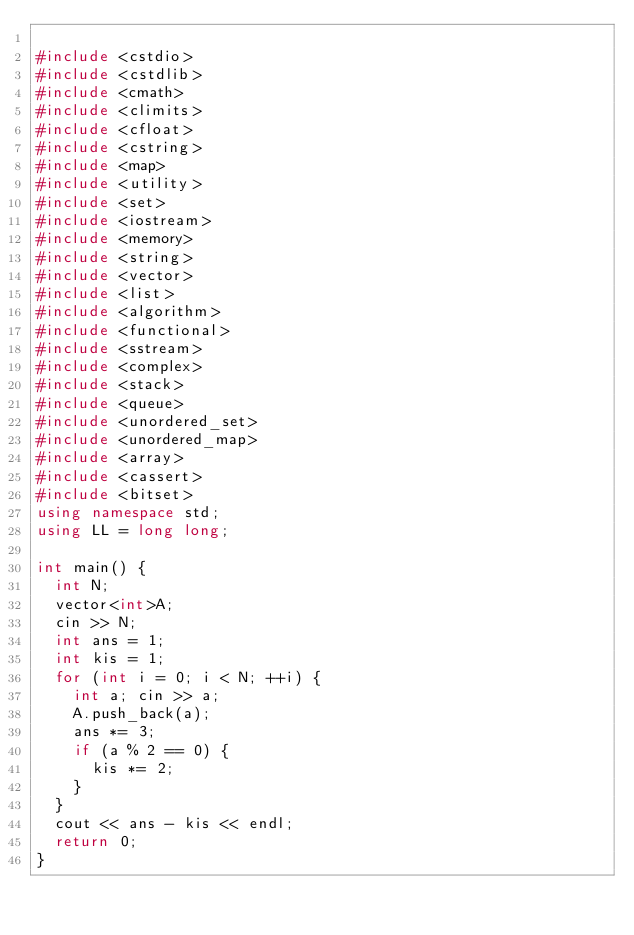<code> <loc_0><loc_0><loc_500><loc_500><_C++_>
#include <cstdio>
#include <cstdlib>
#include <cmath>
#include <climits>
#include <cfloat>
#include <cstring>
#include <map>
#include <utility>
#include <set>
#include <iostream>
#include <memory>
#include <string>
#include <vector>
#include <list>
#include <algorithm>
#include <functional>
#include <sstream>
#include <complex>
#include <stack>
#include <queue>
#include <unordered_set>
#include <unordered_map>
#include <array>
#include <cassert>
#include <bitset>
using namespace std;
using LL = long long;

int main() {
	int N;
	vector<int>A;
	cin >> N;
	int ans = 1;
	int kis = 1;
	for (int i = 0; i < N; ++i) {
		int a; cin >> a;
		A.push_back(a);
		ans *= 3;
		if (a % 2 == 0) {
			kis *= 2;
		}
	}
	cout << ans - kis << endl;
	return 0;
}
</code> 